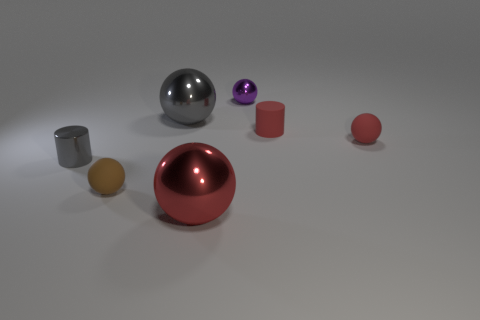Subtract all small rubber balls. How many balls are left? 3 Add 3 purple metal cylinders. How many objects exist? 10 Subtract all purple balls. How many balls are left? 4 Subtract all spheres. How many objects are left? 2 Subtract 2 cylinders. How many cylinders are left? 0 Subtract all blue spheres. Subtract all yellow cylinders. How many spheres are left? 5 Subtract all yellow spheres. How many yellow cylinders are left? 0 Add 3 cylinders. How many cylinders are left? 5 Add 4 purple balls. How many purple balls exist? 5 Subtract 0 red blocks. How many objects are left? 7 